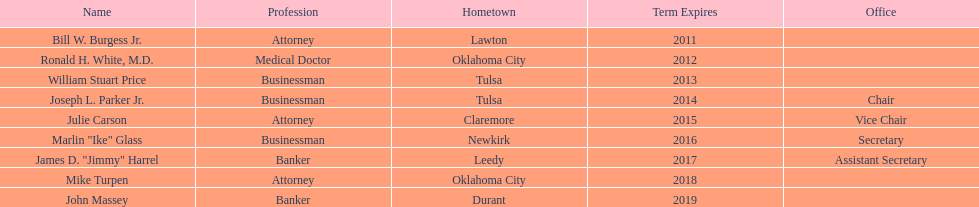Which regents come from tulsa? William Stuart Price, Joseph L. Parker Jr. Which one is not joseph parker, jr.? William Stuart Price. 